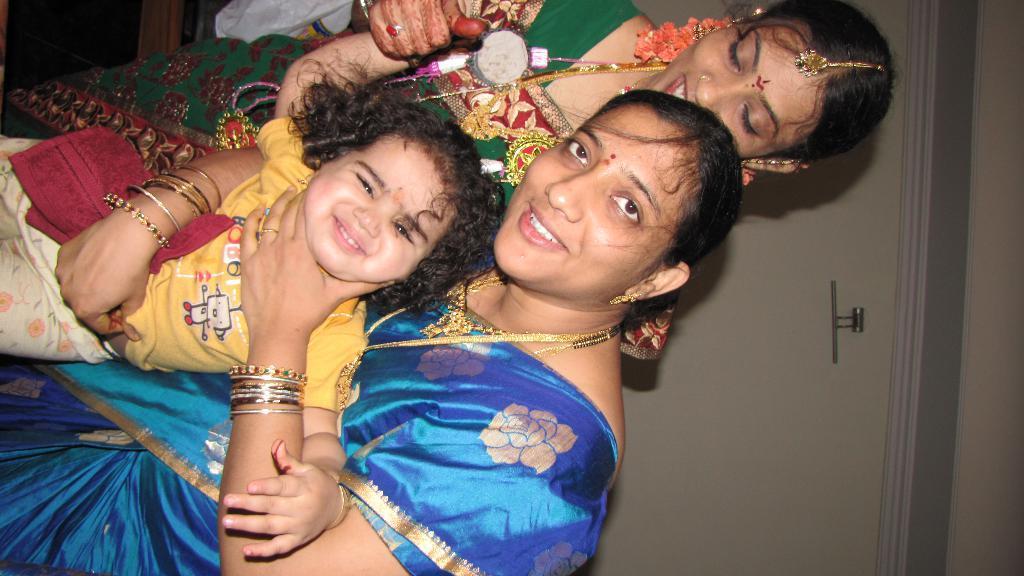Please provide a concise description of this image. In this image I can see two women and a girl. I can see both of them are wearing saree and here I can see she is wearing yellow dress. I can also see maroon colour cloth and I can see smile on few faces. 